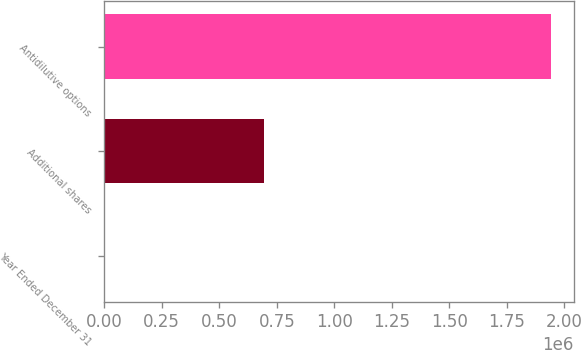<chart> <loc_0><loc_0><loc_500><loc_500><bar_chart><fcel>Year Ended December 31<fcel>Additional shares<fcel>Antidilutive options<nl><fcel>2016<fcel>694700<fcel>1.9435e+06<nl></chart> 